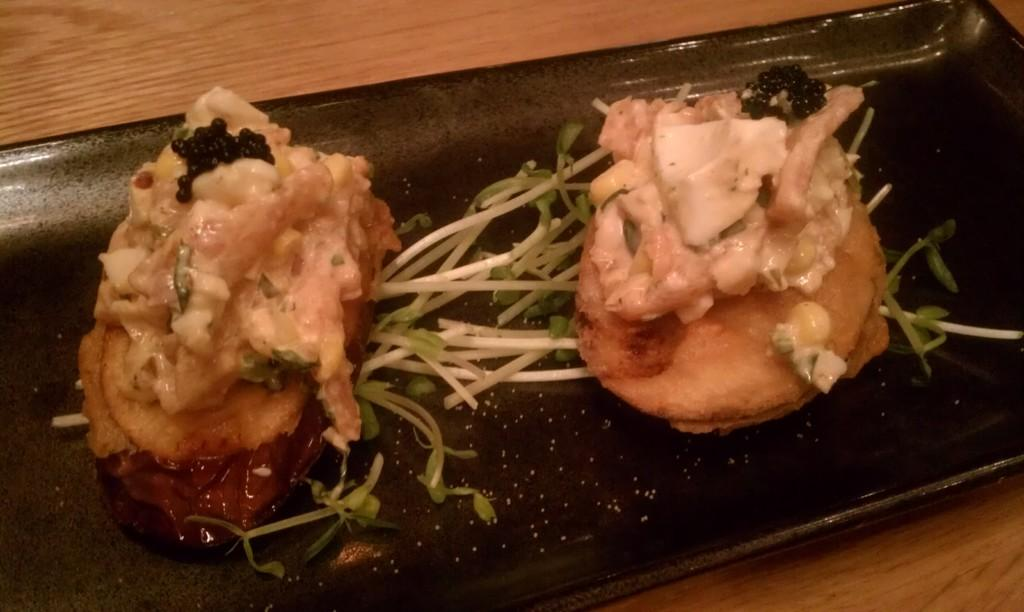What is present on the plate in the image? The food is on a plate in the image. Can you describe the color of the plate? The plate is black. What type of table is visible in the image? There is a wooden table in the image. How many trees can be seen in the image? There are no trees visible in the image; it features food on a plate and a wooden table. Is the image completely silent, or can any sounds be heard? The image is a still image and does not convey any sounds, so it cannot be determined if it is silent or not. 